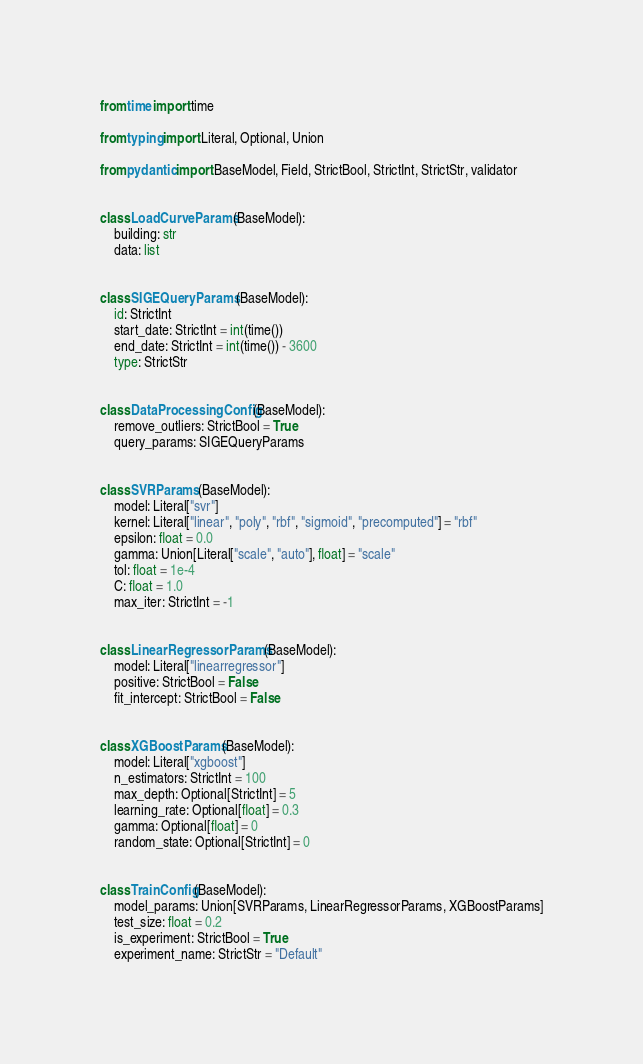<code> <loc_0><loc_0><loc_500><loc_500><_Python_>from time import time

from typing import Literal, Optional, Union

from pydantic import BaseModel, Field, StrictBool, StrictInt, StrictStr, validator


class LoadCurveParams(BaseModel):
    building: str
    data: list


class SIGEQueryParams(BaseModel):
    id: StrictInt
    start_date: StrictInt = int(time())
    end_date: StrictInt = int(time()) - 3600
    type: StrictStr


class DataProcessingConfig(BaseModel):
    remove_outliers: StrictBool = True
    query_params: SIGEQueryParams


class SVRParams(BaseModel):
    model: Literal["svr"]
    kernel: Literal["linear", "poly", "rbf", "sigmoid", "precomputed"] = "rbf"
    epsilon: float = 0.0
    gamma: Union[Literal["scale", "auto"], float] = "scale"
    tol: float = 1e-4
    C: float = 1.0
    max_iter: StrictInt = -1


class LinearRegressorParams(BaseModel):
    model: Literal["linearregressor"]
    positive: StrictBool = False
    fit_intercept: StrictBool = False


class XGBoostParams(BaseModel):
    model: Literal["xgboost"]
    n_estimators: StrictInt = 100
    max_depth: Optional[StrictInt] = 5
    learning_rate: Optional[float] = 0.3
    gamma: Optional[float] = 0
    random_state: Optional[StrictInt] = 0


class TrainConfig(BaseModel):
    model_params: Union[SVRParams, LinearRegressorParams, XGBoostParams]
    test_size: float = 0.2
    is_experiment: StrictBool = True
    experiment_name: StrictStr = "Default"
</code> 